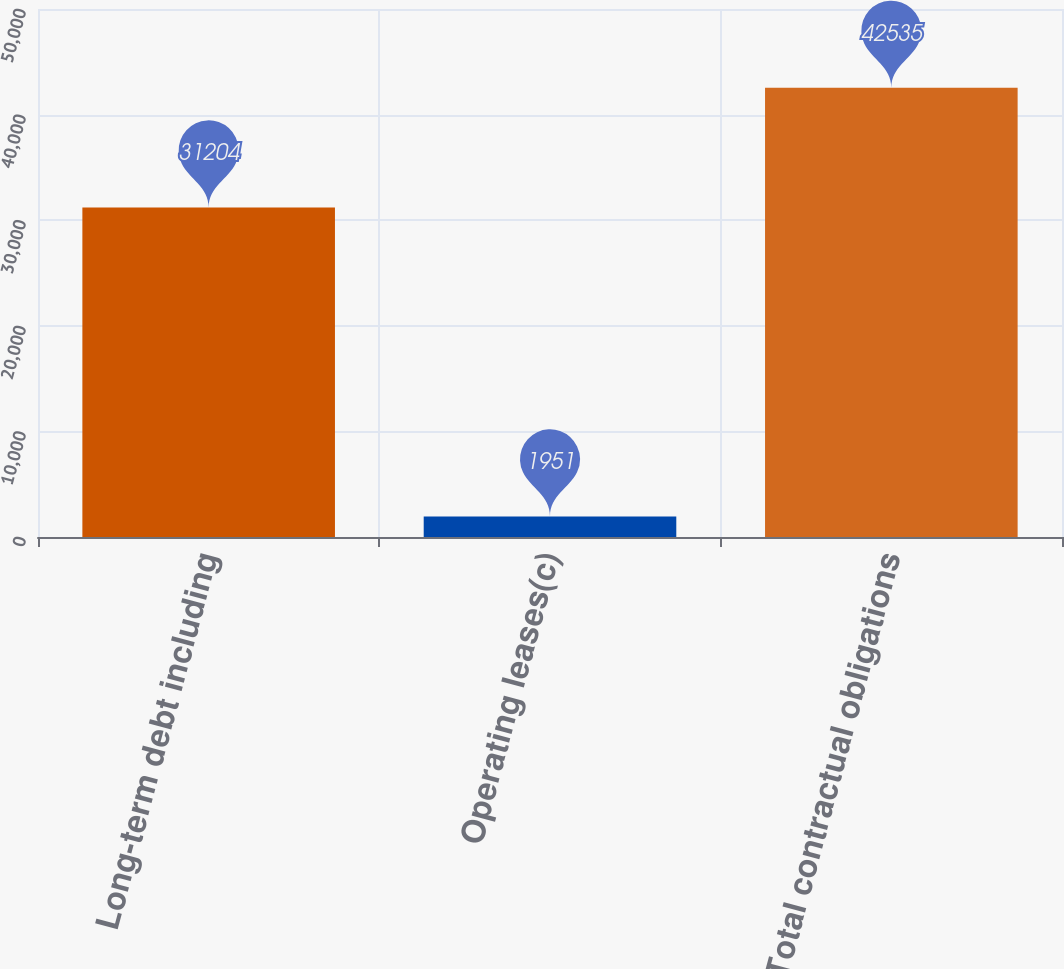Convert chart to OTSL. <chart><loc_0><loc_0><loc_500><loc_500><bar_chart><fcel>Long-term debt including<fcel>Operating leases(c)<fcel>Total contractual obligations<nl><fcel>31204<fcel>1951<fcel>42535<nl></chart> 